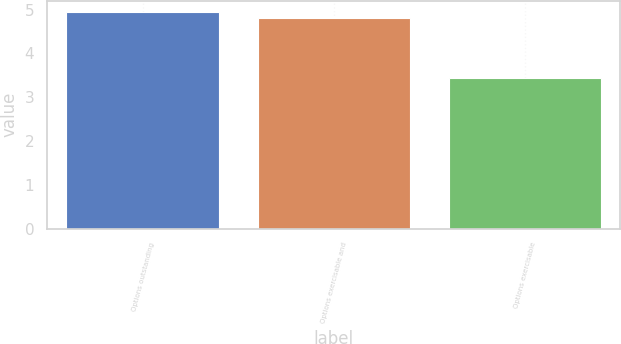Convert chart to OTSL. <chart><loc_0><loc_0><loc_500><loc_500><bar_chart><fcel>Options outstanding<fcel>Options exercisable and<fcel>Options exercisable<nl><fcel>4.95<fcel>4.8<fcel>3.45<nl></chart> 